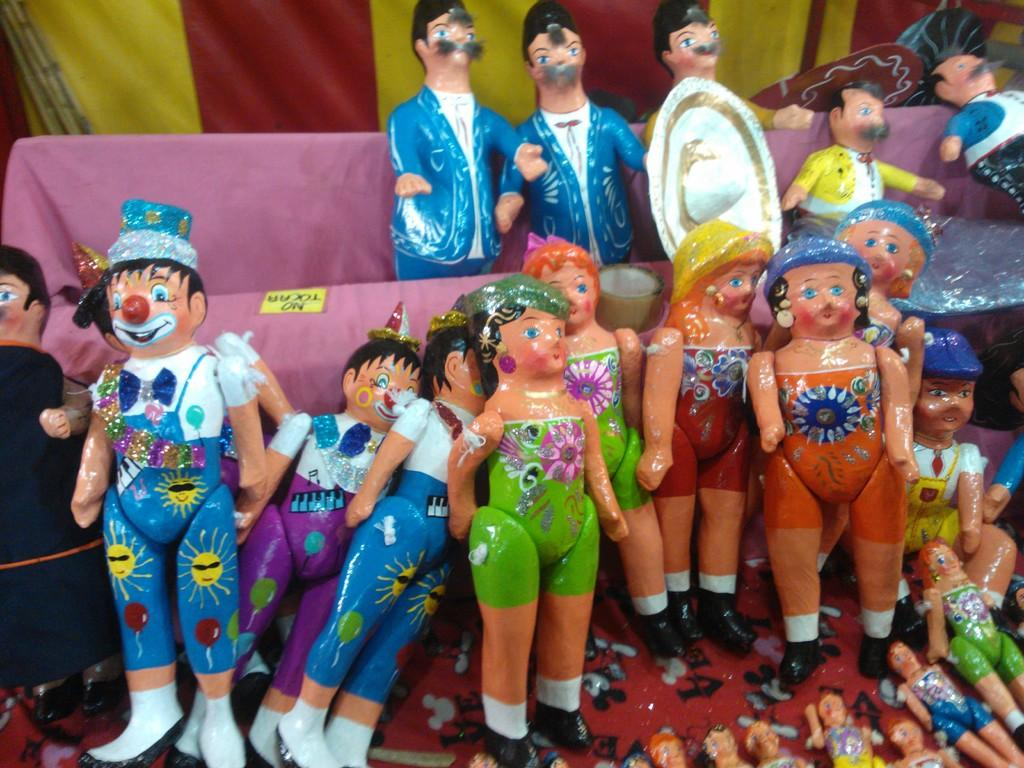What objects can be seen in the image? There are toys in the image. How are some of the toys arranged in the image? Some of the toys are in a box. What type of drain is visible in the image? There is no drain present in the image; it features toys, some of which are in a box. What type of zebra can be seen interacting with the toys in the image? There is no zebra present in the image; it features toys, some of which are in a box. 